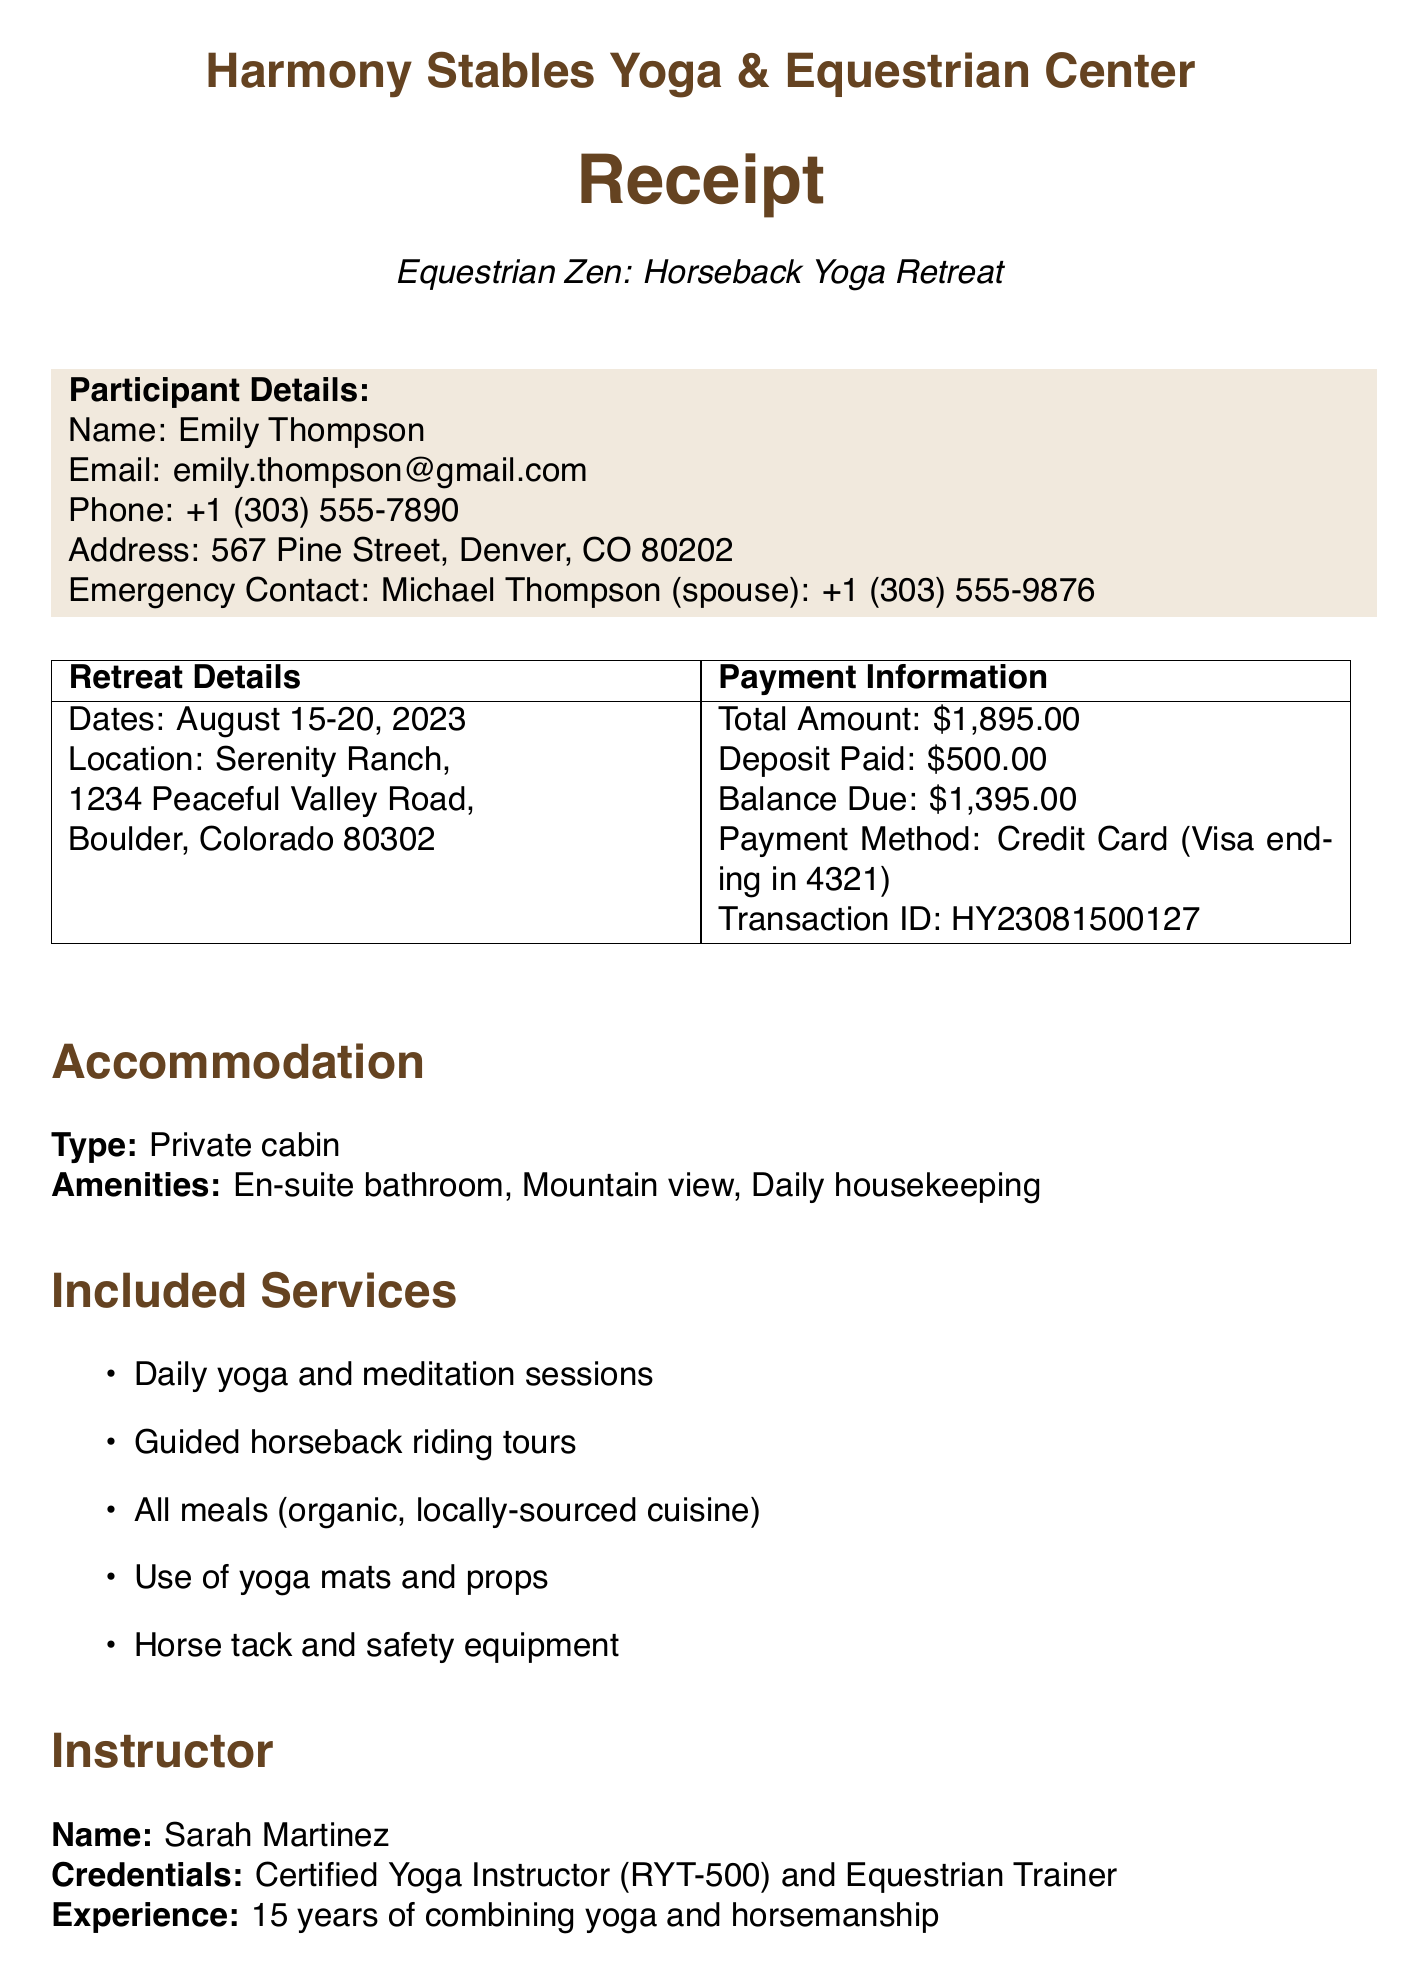What is the name of the retreat? The name of the retreat is specified at the top of the document.
Answer: Equestrian Zen: Horseback Yoga Retreat Who is the organizer? The organizer's name is mentioned under retreat details.
Answer: Harmony Stables Yoga & Equestrian Center What is the total amount due? The total amount due is listed in the payment information section.
Answer: $1,895.00 What type of accommodation is provided? The accommodation type is indicated in the accommodation section.
Answer: Private cabin How many days does the retreat last? The number of days can be inferred from the given dates.
Answer: 6 days What time is check-in on Day 1? The time for check-in is stated in the Day 1 schedule.
Answer: 2:00 PM Who is the instructor? The name of the instructor is mentioned in the instructor section.
Answer: Sarah Martinez What is the cancellation policy for a full refund? The cancellation policy for a full refund is noted in the cancellation policy section.
Answer: Up to 30 days before the retreat start date What meals are included in the retreat? The included services section lists the meals provided.
Answer: All meals (organic, locally-sourced cuisine) 